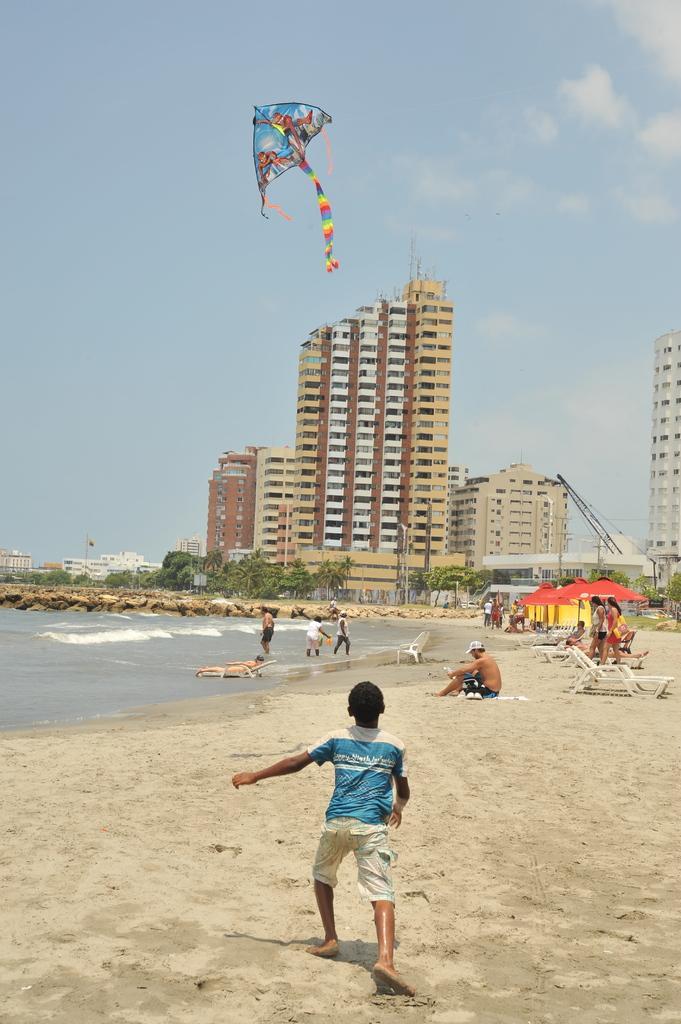Can you describe this image briefly? In this picture we can see some people are walking, some people are standing on the sand and some people are sitting on the sand and some are sitting on chairs. Behind the people there are poles with umbrella shaped structures. Behind the umbrella shaped structures there are buildings, trees and the sky. On the left side of the people there is the sea and a kite is flying in the air. 